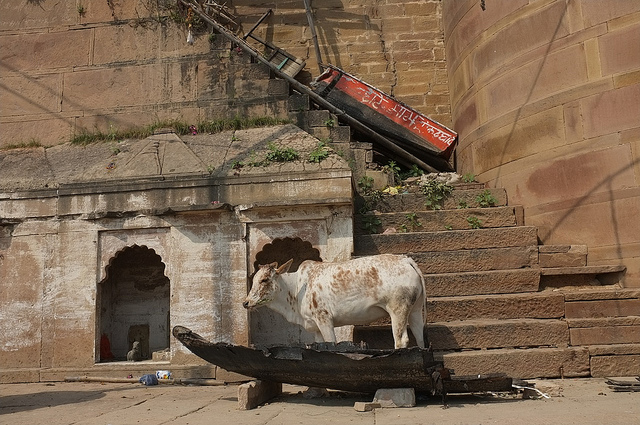Are there any other objects or elements near the cow that draw attention? Yes, there's a red banner with inscriptions hanging askew on the staircase, which adds a vibrant splash of color and perhaps a cultural or religious significance to the setting. 